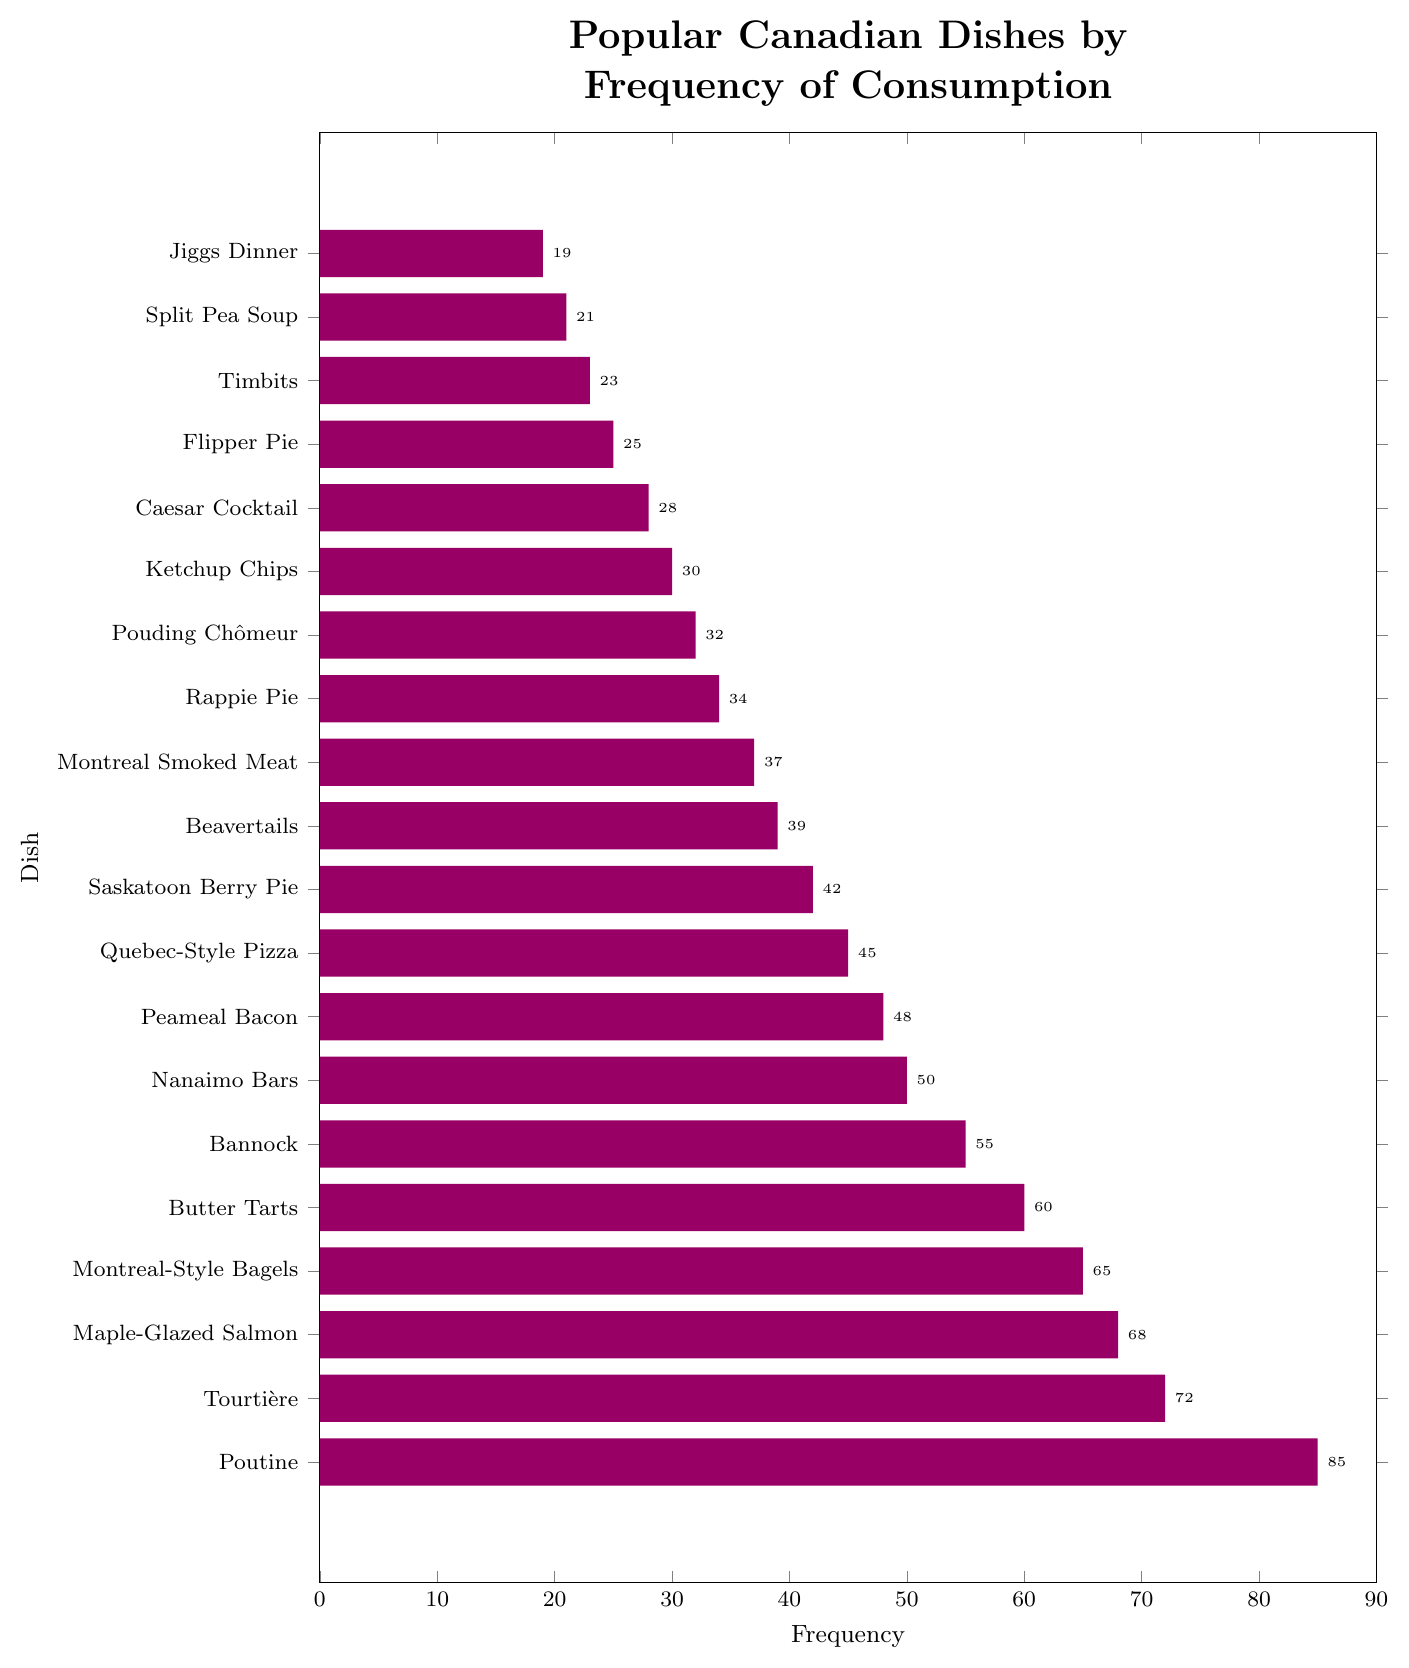Which dish is consumed the most frequently? By observing the bar length, we see that "Poutine" has the longest bar, indicating the highest frequency.
Answer: Poutine What is the total frequency of the top three most consumed dishes? By adding the frequencies of "Poutine" (85), "Tourtière" (72), and "Maple-Glazed Salmon" (68) as they have the longest bars among the dishes, we get 85 + 72 + 68 = 225.
Answer: 225 Which dish has a higher frequency of consumption, "Nanaimo Bars" or "Quebec-Style Pizza"? By comparing the bar lengths of "Nanaimo Bars" (50) and "Quebec-Style Pizza" (45), we can see that "Nanaimo Bars" has a higher frequency.
Answer: Nanaimo Bars What is the average frequency of consumption for "Jiggs Dinner" and "Timbits"? By adding the frequencies of "Jiggs Dinner" (19) and "Timbits" (23) and then dividing by 2, (19 + 23)/2 = 21.
Answer: 21 How much more frequently is "Butter Tarts" consumed compared to "Beavertails"? By finding the difference in their frequencies: 60 (Butter Tarts) - 39 (Beavertails) = 21.
Answer: 21 Which dishes have a frequency of consumption between 30 and 40? By identifying the bars within this range, we find "Ketchup Chips" (30), "Pouding Chômeur" (32), "Rappie Pie" (34), "Montreal Smoked Meat" (37), and "Beavertails" (39).
Answer: Ketchup Chips, Pouding Chômeur, Rappie Pie, Montreal Smoked Meat, Beavertails Is "Flipper Pie" consumed less frequently than "Caesar Cocktail"? By comparing their bar lengths, "Flipper Pie" has a frequency of 25, which is less than "Caesar Cocktail" at 28.
Answer: Yes Which dish ranks exactly in the middle in terms of frequency? By ordering the dishes by frequency, the median is the dish at position 10 (out of 20). "Beavertails" has the frequency rank of 10th, with 39.
Answer: Beavertails How many dishes have a consumption frequency of less than 50? By counting the dishes with bars shorter than 50, there are 12 such dishes.
Answer: 12 